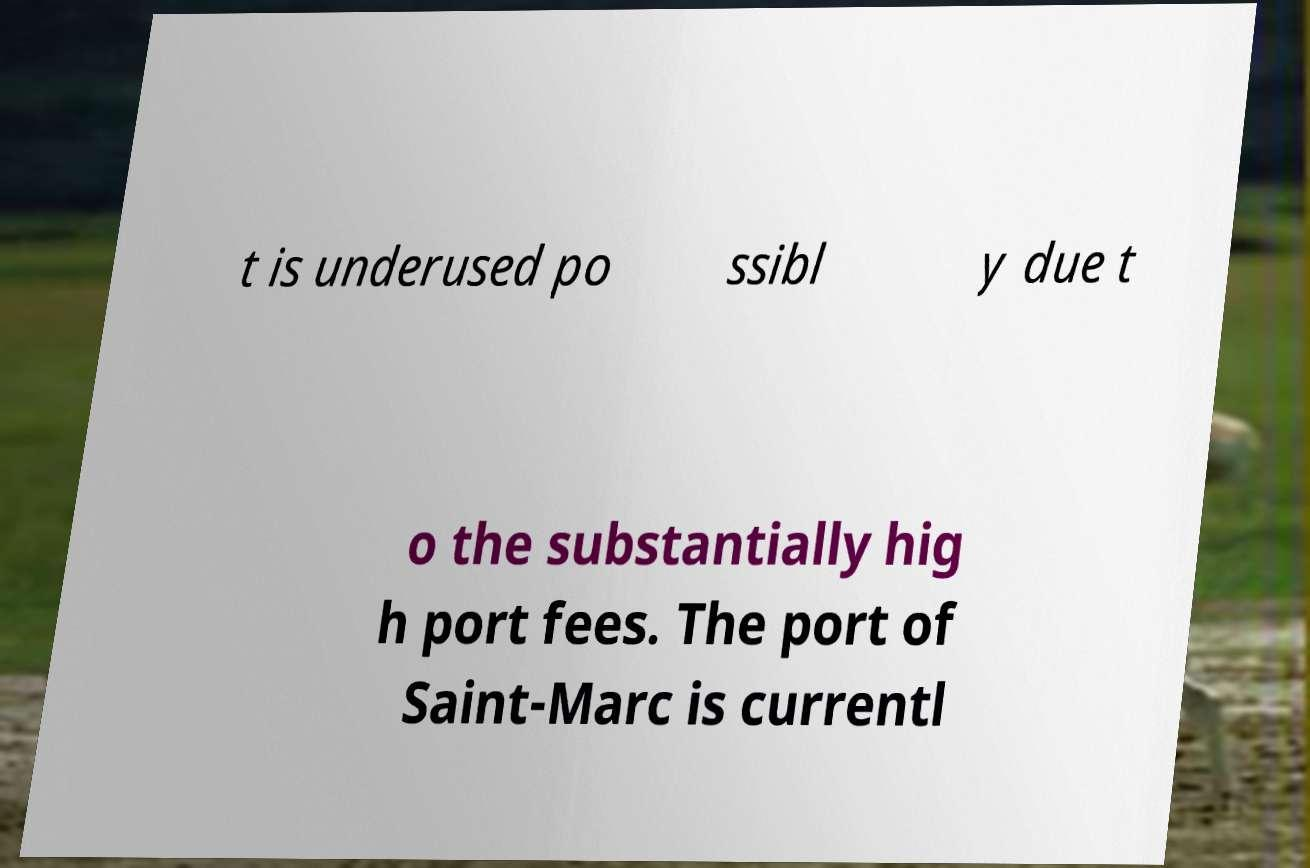What messages or text are displayed in this image? I need them in a readable, typed format. t is underused po ssibl y due t o the substantially hig h port fees. The port of Saint-Marc is currentl 